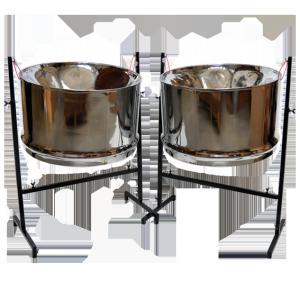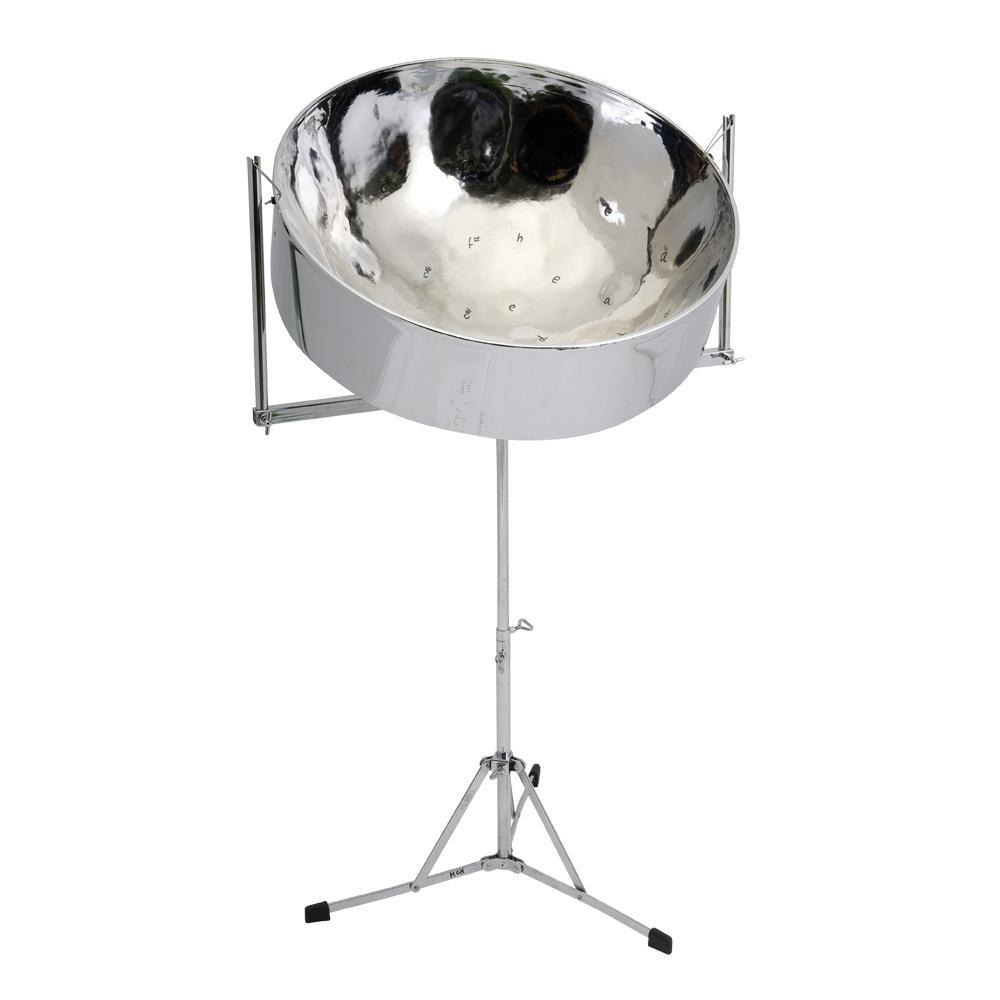The first image is the image on the left, the second image is the image on the right. Assess this claim about the two images: "Each image shows one cylindrical metal drum with a concave top, and the drums on the right and left have similar shaped stands.". Correct or not? Answer yes or no. No. The first image is the image on the left, the second image is the image on the right. Considering the images on both sides, is "Exactly two drums are attached to floor stands, which are different, but with the same style of feet." valid? Answer yes or no. No. 